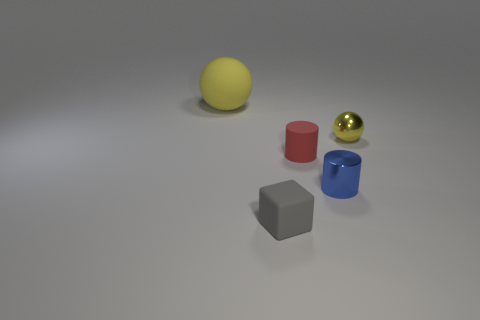What number of cyan things are either shiny things or tiny spheres?
Make the answer very short. 0. Is the number of matte balls that are in front of the tiny red rubber cylinder the same as the number of blue shiny cylinders that are behind the tiny yellow metallic object?
Your answer should be very brief. Yes. What color is the tiny rubber cylinder in front of the yellow thing that is to the left of the ball in front of the big yellow thing?
Your answer should be very brief. Red. Is there anything else that is the same color as the tiny cube?
Provide a succinct answer. No. There is a yellow ball that is on the left side of the blue shiny object; what is its size?
Keep it short and to the point. Large. What shape is the yellow thing that is the same size as the red thing?
Offer a terse response. Sphere. Is the material of the sphere that is to the right of the big matte ball the same as the sphere that is to the left of the small red object?
Give a very brief answer. No. The red cylinder that is left of the tiny cylinder on the right side of the red rubber object is made of what material?
Make the answer very short. Rubber. What is the size of the ball that is behind the yellow ball in front of the yellow thing that is left of the block?
Your response must be concise. Large. Do the red matte cylinder and the shiny sphere have the same size?
Provide a short and direct response. Yes. 